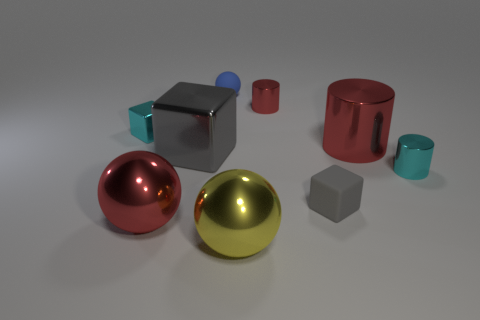There is a cyan cylinder that is the same size as the cyan metal cube; what is its material?
Keep it short and to the point. Metal. What number of things are tiny red metallic objects or red things right of the small gray object?
Provide a succinct answer. 2. There is a gray rubber object; is its size the same as the gray cube to the left of the small matte sphere?
Offer a very short reply. No. How many cylinders are either tiny red shiny objects or tiny cyan metallic objects?
Give a very brief answer. 2. How many tiny rubber things are both behind the tiny cyan metal cube and right of the tiny blue rubber ball?
Your answer should be compact. 0. How many other things are the same color as the large metal cylinder?
Your answer should be very brief. 2. What shape is the big red thing right of the tiny gray matte object?
Keep it short and to the point. Cylinder. Is the tiny gray block made of the same material as the blue object?
Make the answer very short. Yes. Are there any other things that are the same size as the blue object?
Your answer should be compact. Yes. There is a small gray rubber cube; how many red shiny balls are behind it?
Your answer should be very brief. 0. 